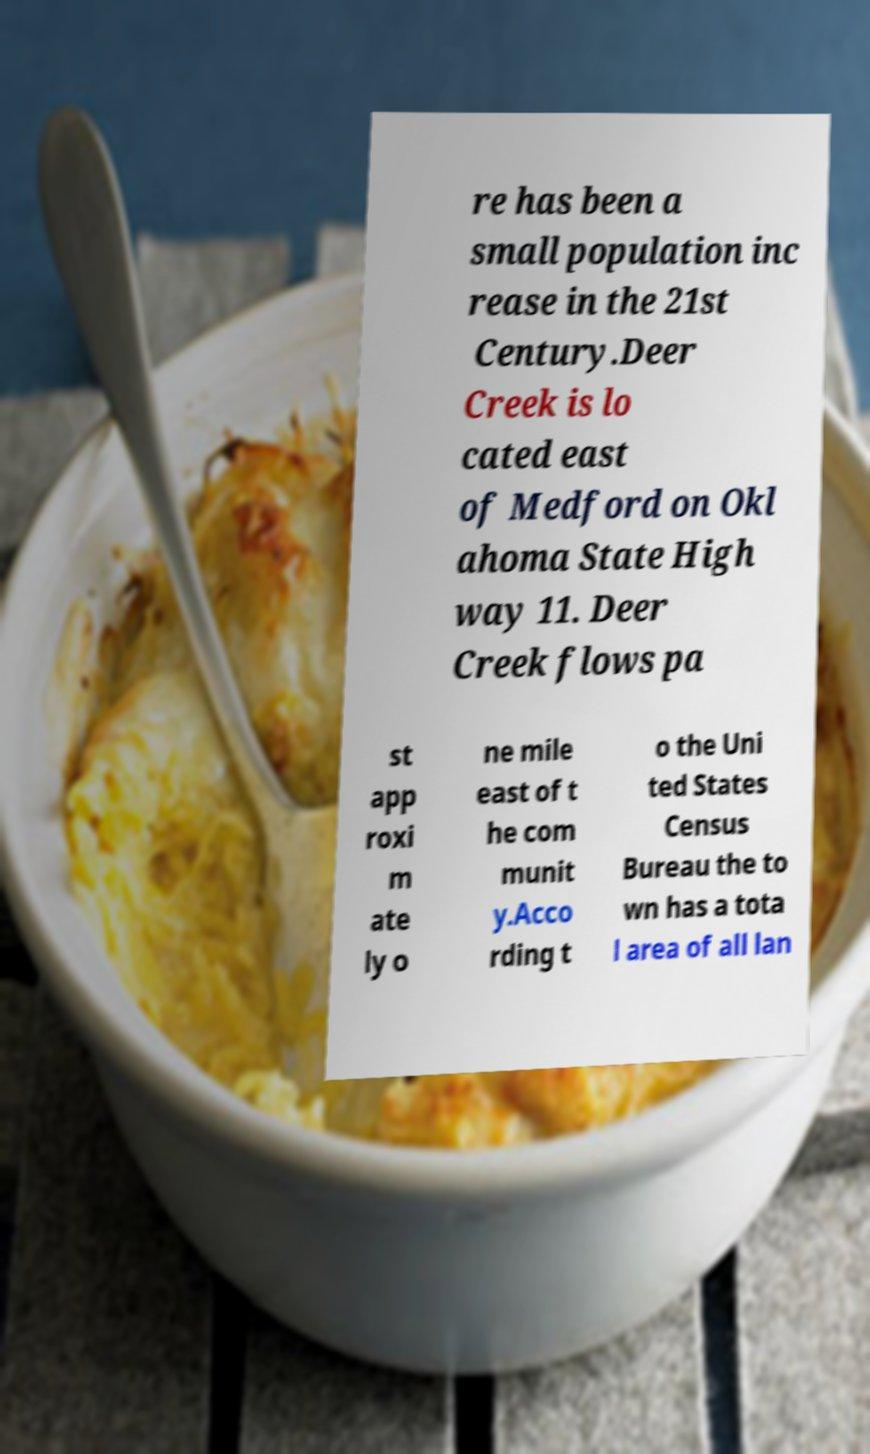Please identify and transcribe the text found in this image. re has been a small population inc rease in the 21st Century.Deer Creek is lo cated east of Medford on Okl ahoma State High way 11. Deer Creek flows pa st app roxi m ate ly o ne mile east of t he com munit y.Acco rding t o the Uni ted States Census Bureau the to wn has a tota l area of all lan 